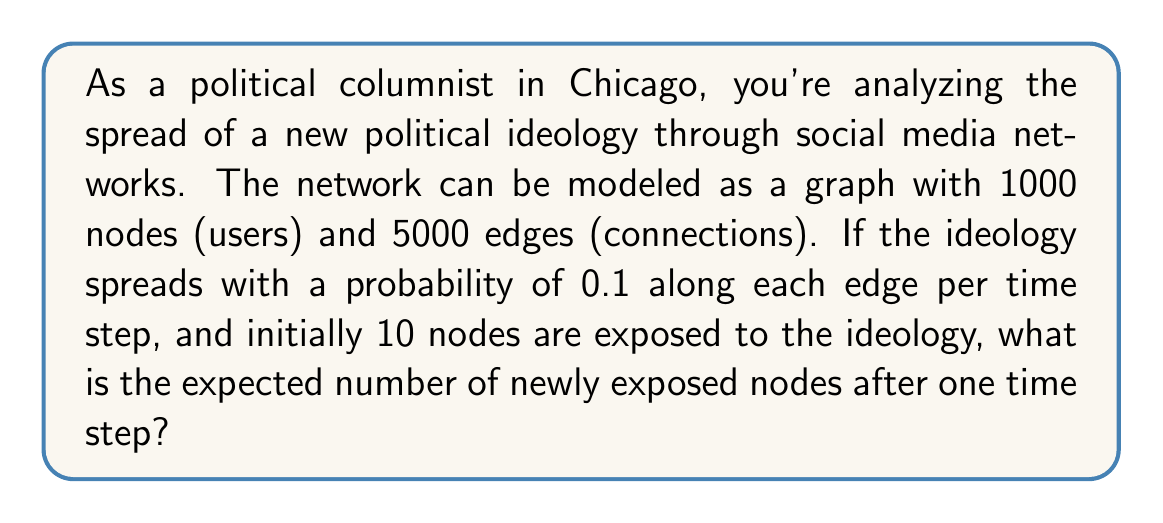Provide a solution to this math problem. Let's approach this step-by-step:

1) First, we need to understand what the question is asking. We're looking for the expected number of new nodes exposed to the ideology after one time step.

2) We know that:
   - There are 1000 nodes in total
   - 10 nodes are initially exposed
   - There are 5000 edges in the network
   - The probability of spreading along an edge is 0.1

3) Let's consider the unexposed nodes. There are 1000 - 10 = 990 unexposed nodes.

4) Now, we need to calculate the probability that an unexposed node becomes exposed. This happens if the ideology spreads along at least one of the edges connected to this node from an exposed node.

5) On average, each node has $\frac{5000}{1000} = 5$ edges.

6) The probability that an unexposed node is connected to an exposed node is approximately:

   $$P(\text{connected to exposed}) = 1 - (1 - \frac{10}{1000})^5 \approx 0.0488$$

7) If an unexposed node is connected to an exposed node, the probability of becoming exposed is:

   $$P(\text{becoming exposed | connected}) = 1 - (1 - 0.1)^1 = 0.1$$

8) Therefore, the probability of an unexposed node becoming exposed in this time step is:

   $$P(\text{becoming exposed}) = 0.0488 * 0.1 \approx 0.00488$$

9) The expected number of newly exposed nodes is the number of unexposed nodes multiplied by this probability:

   $$E(\text{newly exposed}) = 990 * 0.00488 \approx 4.83$$
Answer: 4.83 